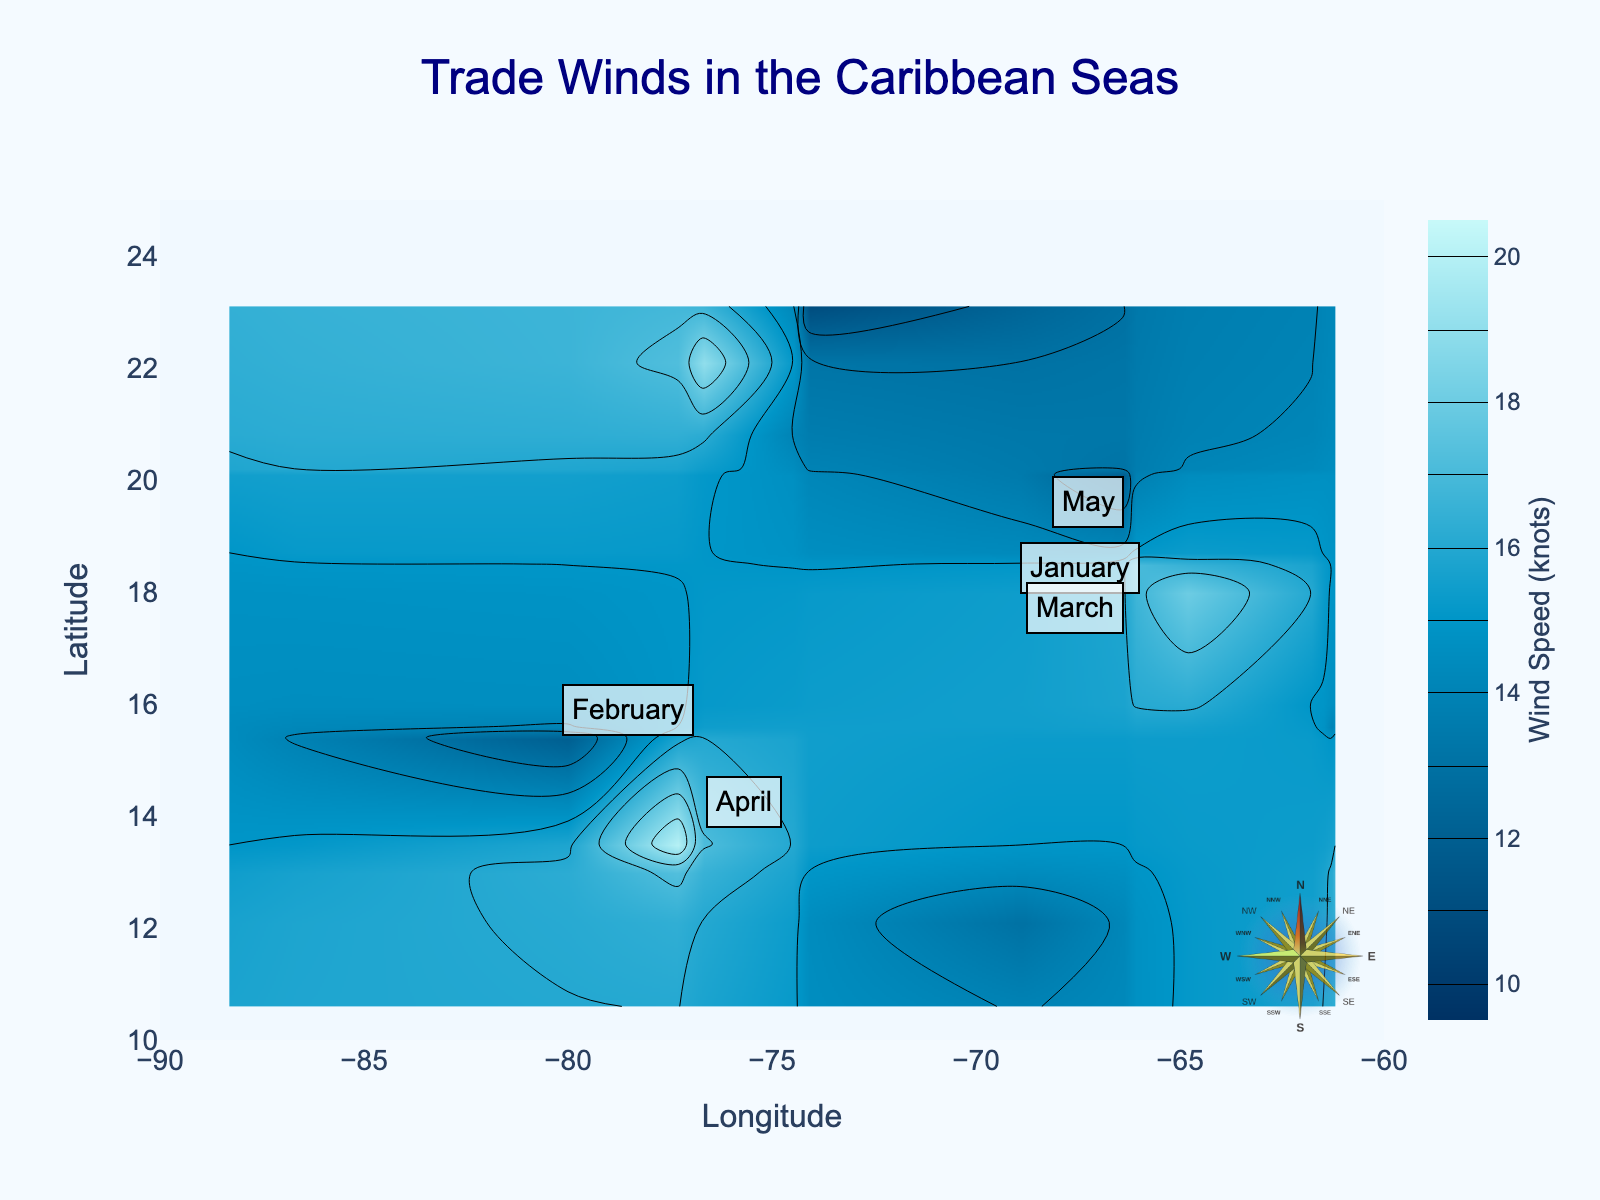What is the title of the figure? The title is often displayed at the top and is prominently larger in size compared to other texts.
Answer: Trade Winds in the Caribbean Seas What range of longitudes is displayed in the figure? The x-axis label and tick marks provide the range of longitudes.
Answer: -90 to -60 Which month has the data point with the highest wind speed? By looking at the contour colors and annotated months, identify the region with the darkest color representing the highest wind speed, then check the annotated month.
Answer: April What is the range of wind speeds depicted in the figure? The color bar on the right side provides the range of wind speeds illustrated by different colors.
Answer: 10 to 20 knots How many months' data are annotated in the figure? Count the number of unique month annotations present in the plot.
Answer: 5 Which annotated month is closest to the coordinates (18, -65)? Look for the annotation that is closest to the specified coordinates.
Answer: March What is the average wind speed at around latitude 20, longitude -75? Look at the color of the contour plot in that region and refer to the color scale to determine the average wind speed.
Answer: 14-15 knots Describe the general trend in wind speed across latitudes from south to north. Observe how the colors change as you move from the bottom (south) to the top (north) of the figure along the y-axis.
Answer: Wind speed generally increases from south to north Which region appears to have the calmest winds? Look for the lightest color on the contours, which indicates the lowest wind speeds according to the color scale.
Answer: Around latitude 23, longitude -74 Are there any regions where wind speed is uniformly high? Identify areas with large contiguous sections of similar dark contour colors, indicating uniformly high wind speeds.
Answer: Around 18 and -65 in March and 13.5 and -77.3 in April 